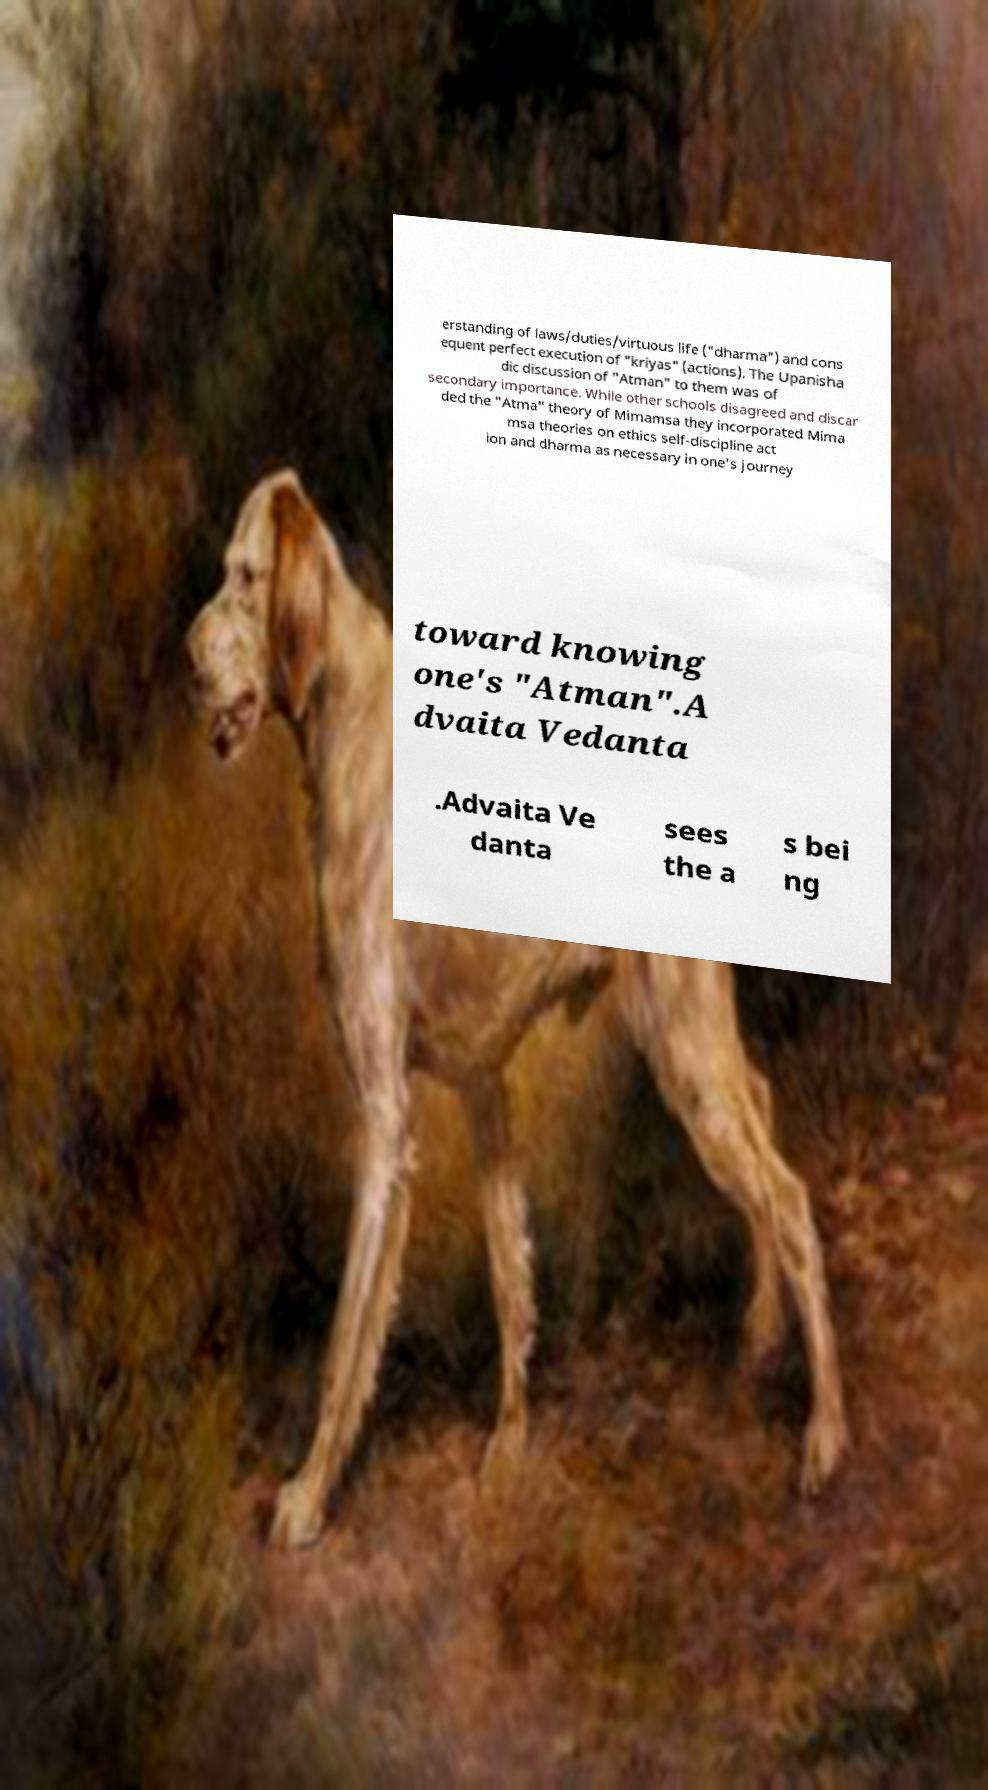Could you assist in decoding the text presented in this image and type it out clearly? erstanding of laws/duties/virtuous life ("dharma") and cons equent perfect execution of "kriyas" (actions). The Upanisha dic discussion of "Atman" to them was of secondary importance. While other schools disagreed and discar ded the "Atma" theory of Mimamsa they incorporated Mima msa theories on ethics self-discipline act ion and dharma as necessary in one's journey toward knowing one's "Atman".A dvaita Vedanta .Advaita Ve danta sees the a s bei ng 